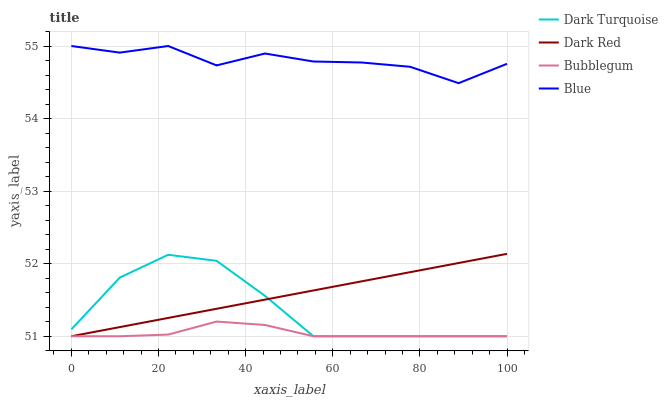Does Dark Turquoise have the minimum area under the curve?
Answer yes or no. No. Does Dark Turquoise have the maximum area under the curve?
Answer yes or no. No. Is Dark Turquoise the smoothest?
Answer yes or no. No. Is Dark Turquoise the roughest?
Answer yes or no. No. Does Dark Turquoise have the highest value?
Answer yes or no. No. Is Dark Turquoise less than Blue?
Answer yes or no. Yes. Is Blue greater than Dark Turquoise?
Answer yes or no. Yes. Does Dark Turquoise intersect Blue?
Answer yes or no. No. 